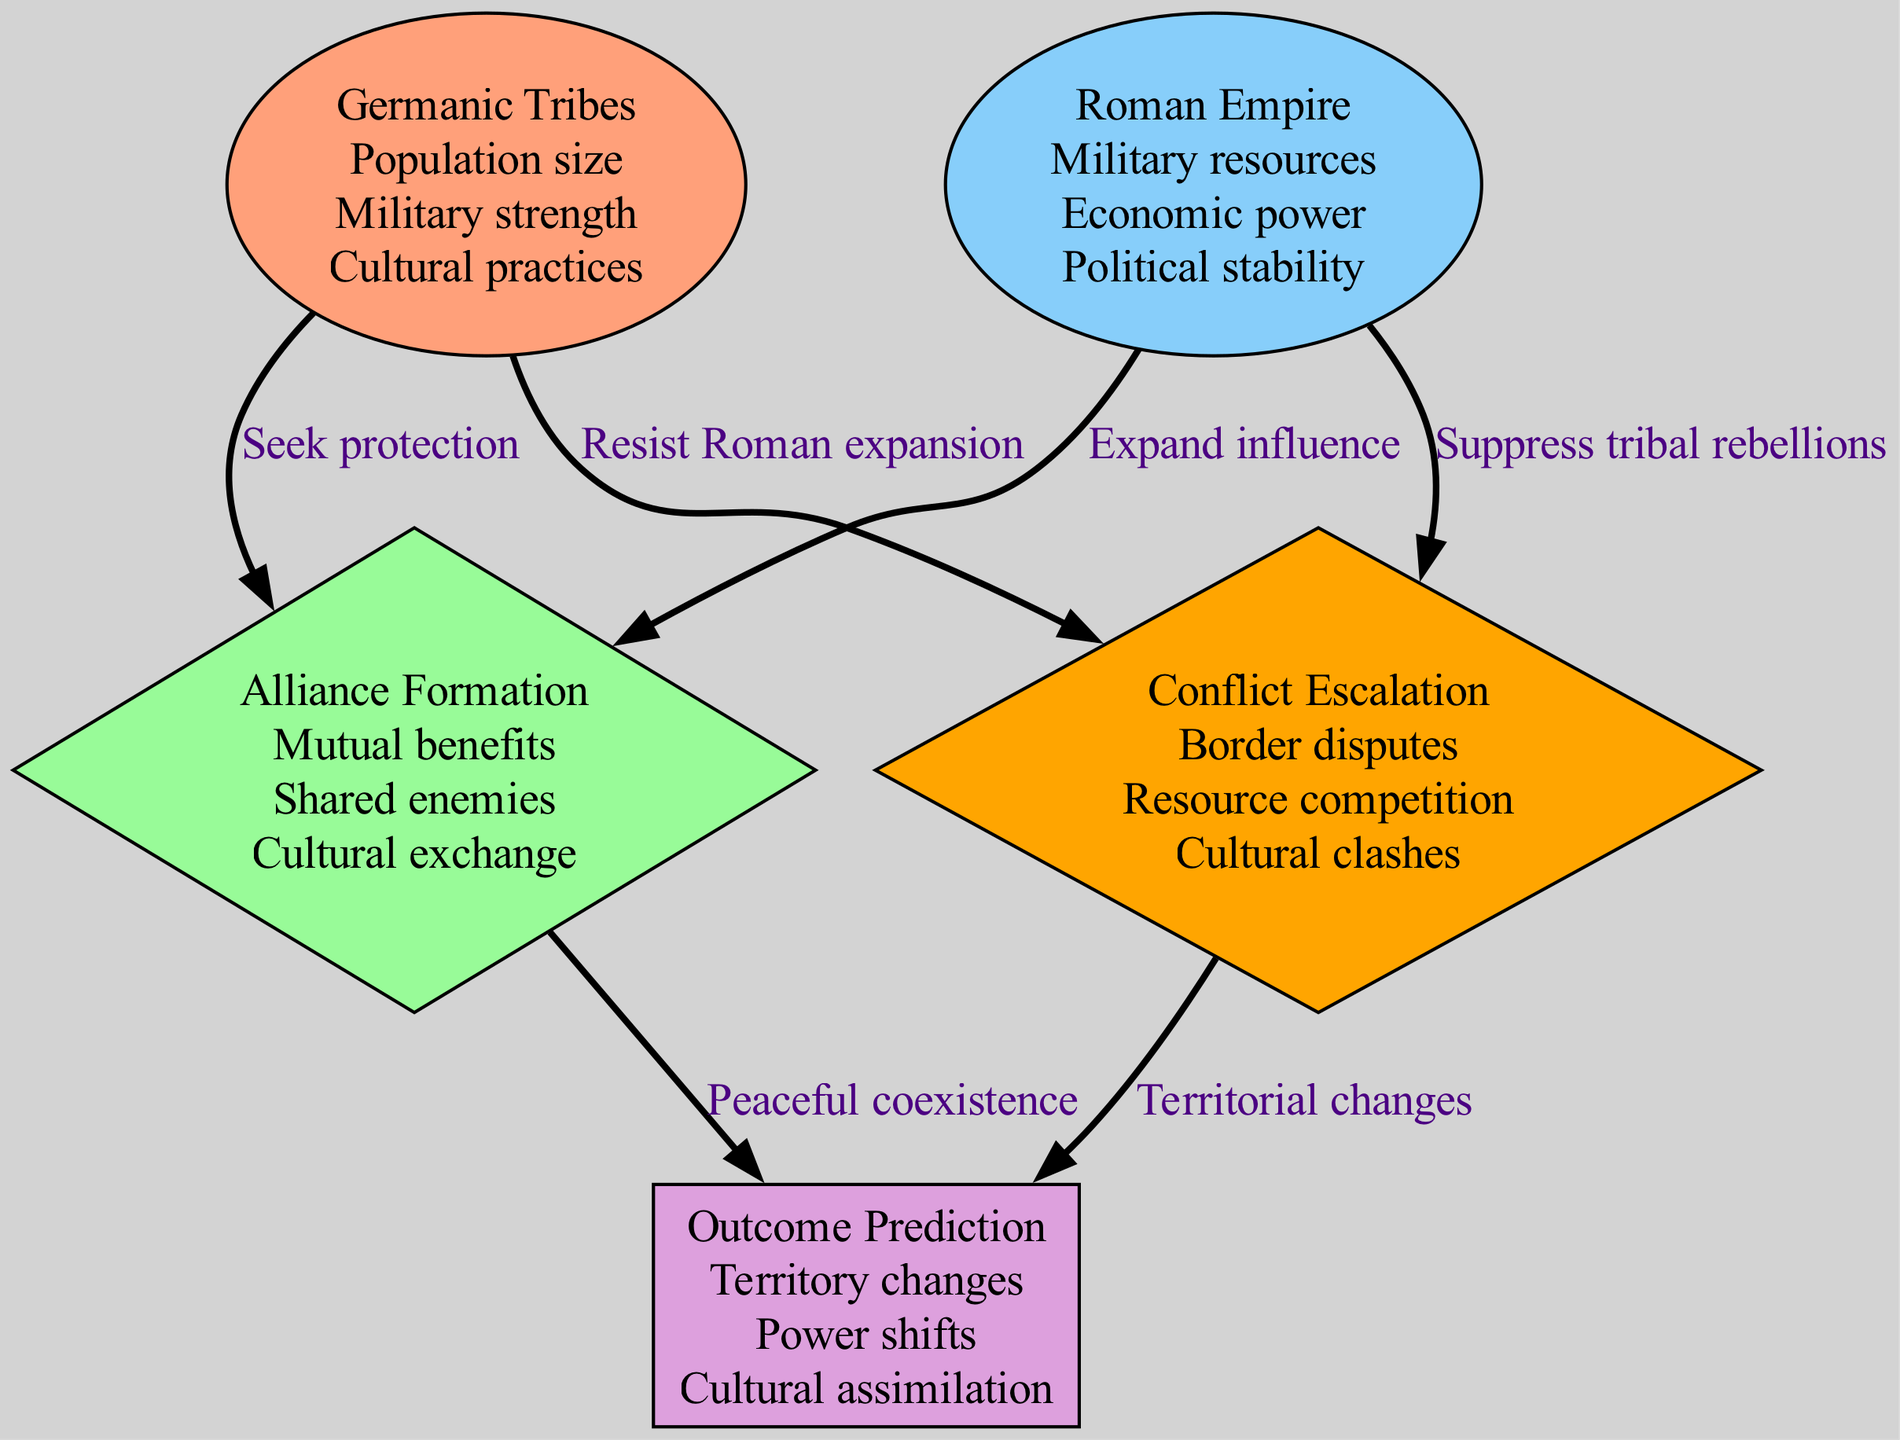What are the features of the Roman Empire node? The Roman Empire node lists the features "Military resources", "Economic power", and "Political stability". This information can be directly observed from the node labeled "Roman Empire" in the diagram.
Answer: Military resources, Economic power, Political stability What is the relationship between Germanic Tribes and Alliance Formation? The diagram shows that the Germanic Tribes node has an edge that leads to the Alliance Formation node labeled "Seek protection". This indicates that Germanic tribes seek to form alliances for protection.
Answer: Seek protection How many nodes are present in the diagram? By counting the nodes visually or by examining the list given in the data, we find there are five nodes: Germanic Tribes, Roman Empire, Alliance Formation, Conflict Escalation, and Outcome Prediction.
Answer: 5 What leads to Outcome Prediction from Conflict Escalation? Conflict Escalation leads to Outcome Prediction via the edge labeled "Territorial changes". The diagram shows that conflicts lead to changes in territory, which is a key part of predicting outcomes.
Answer: Territorial changes What are the features for the Conflict Escalation node? For the Conflict Escalation node, the features listed are "Border disputes", "Resource competition", and "Cultural clashes", which can be seen directly in the diagram without needing to interpret any connections.
Answer: Border disputes, Resource competition, Cultural clashes How do the Germanic Tribes seek to avoid conflicts? The diagram indicates that Germanic Tribes form alliances, primarily through the edge labeled "Seek protection" leading to the Alliance Formation node. This suggests that seeking alliances is a way to mitigate potential conflicts.
Answer: Seek protection What is the edge label between the Roman Empire and Alliance Formation? The diagram shows that the edge labeled between Roman Empire and Alliance Formation is "Expand influence". This indicates the Roman Empire's intent in forming alliances.
Answer: Expand influence Which nodes are connected to the Outcome Prediction node? Outcome Prediction is connected to two nodes: Alliance Formation and Conflict Escalation, which are shown by edges leading into it from both nodes.
Answer: Alliance Formation, Conflict Escalation What feature connects the Alliance Formation node to Outcome Prediction? The feature that connects these nodes is labeled as "Peaceful coexistence". This indicates that successful alliances may result in peaceful situations, contributing to the prediction of outcomes.
Answer: Peaceful coexistence 